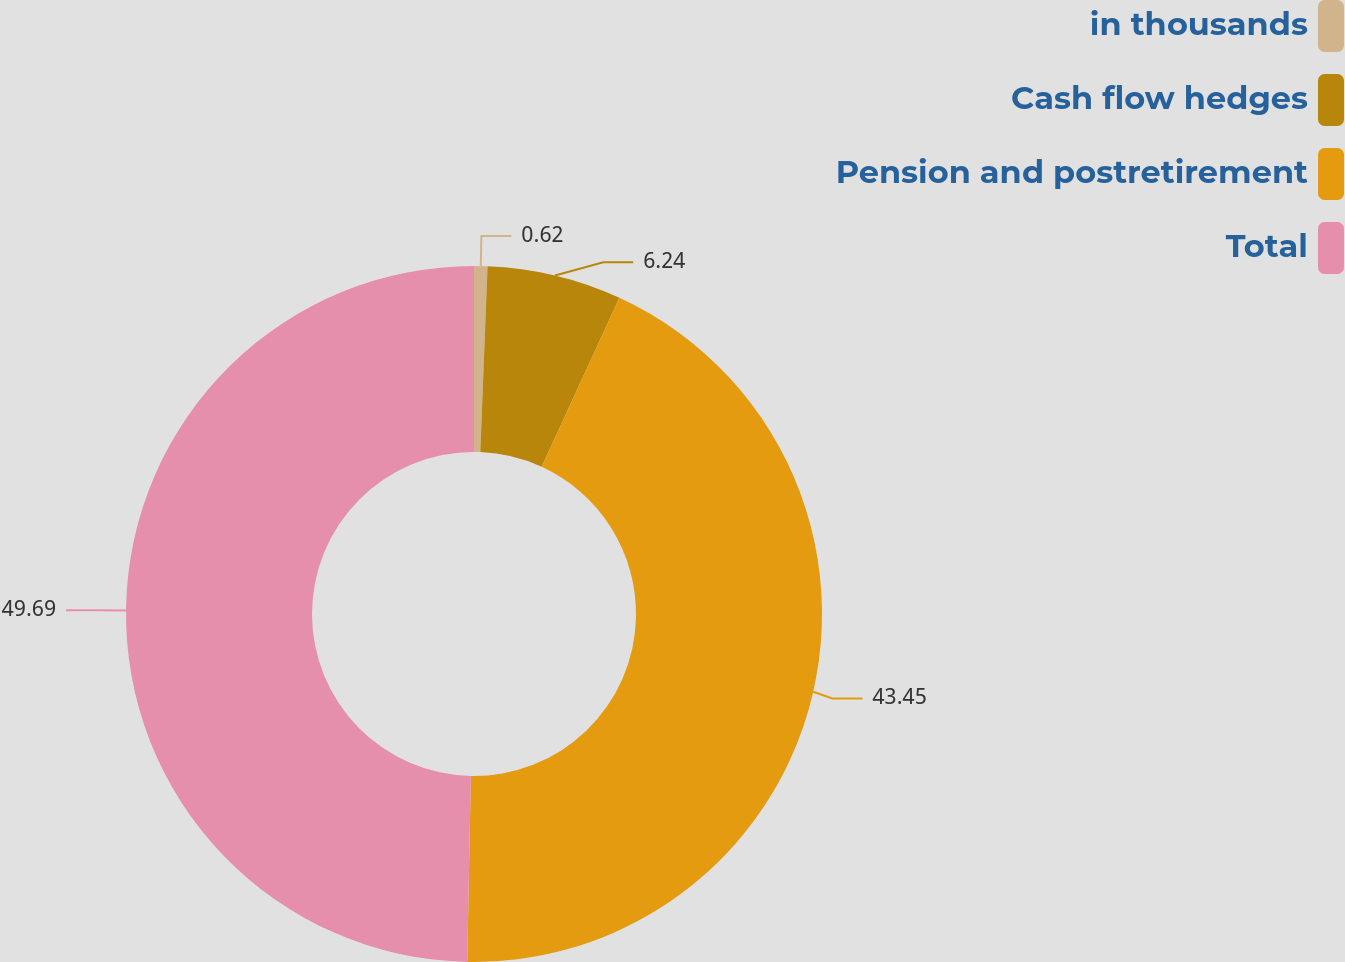Convert chart. <chart><loc_0><loc_0><loc_500><loc_500><pie_chart><fcel>in thousands<fcel>Cash flow hedges<fcel>Pension and postretirement<fcel>Total<nl><fcel>0.62%<fcel>6.24%<fcel>43.45%<fcel>49.69%<nl></chart> 